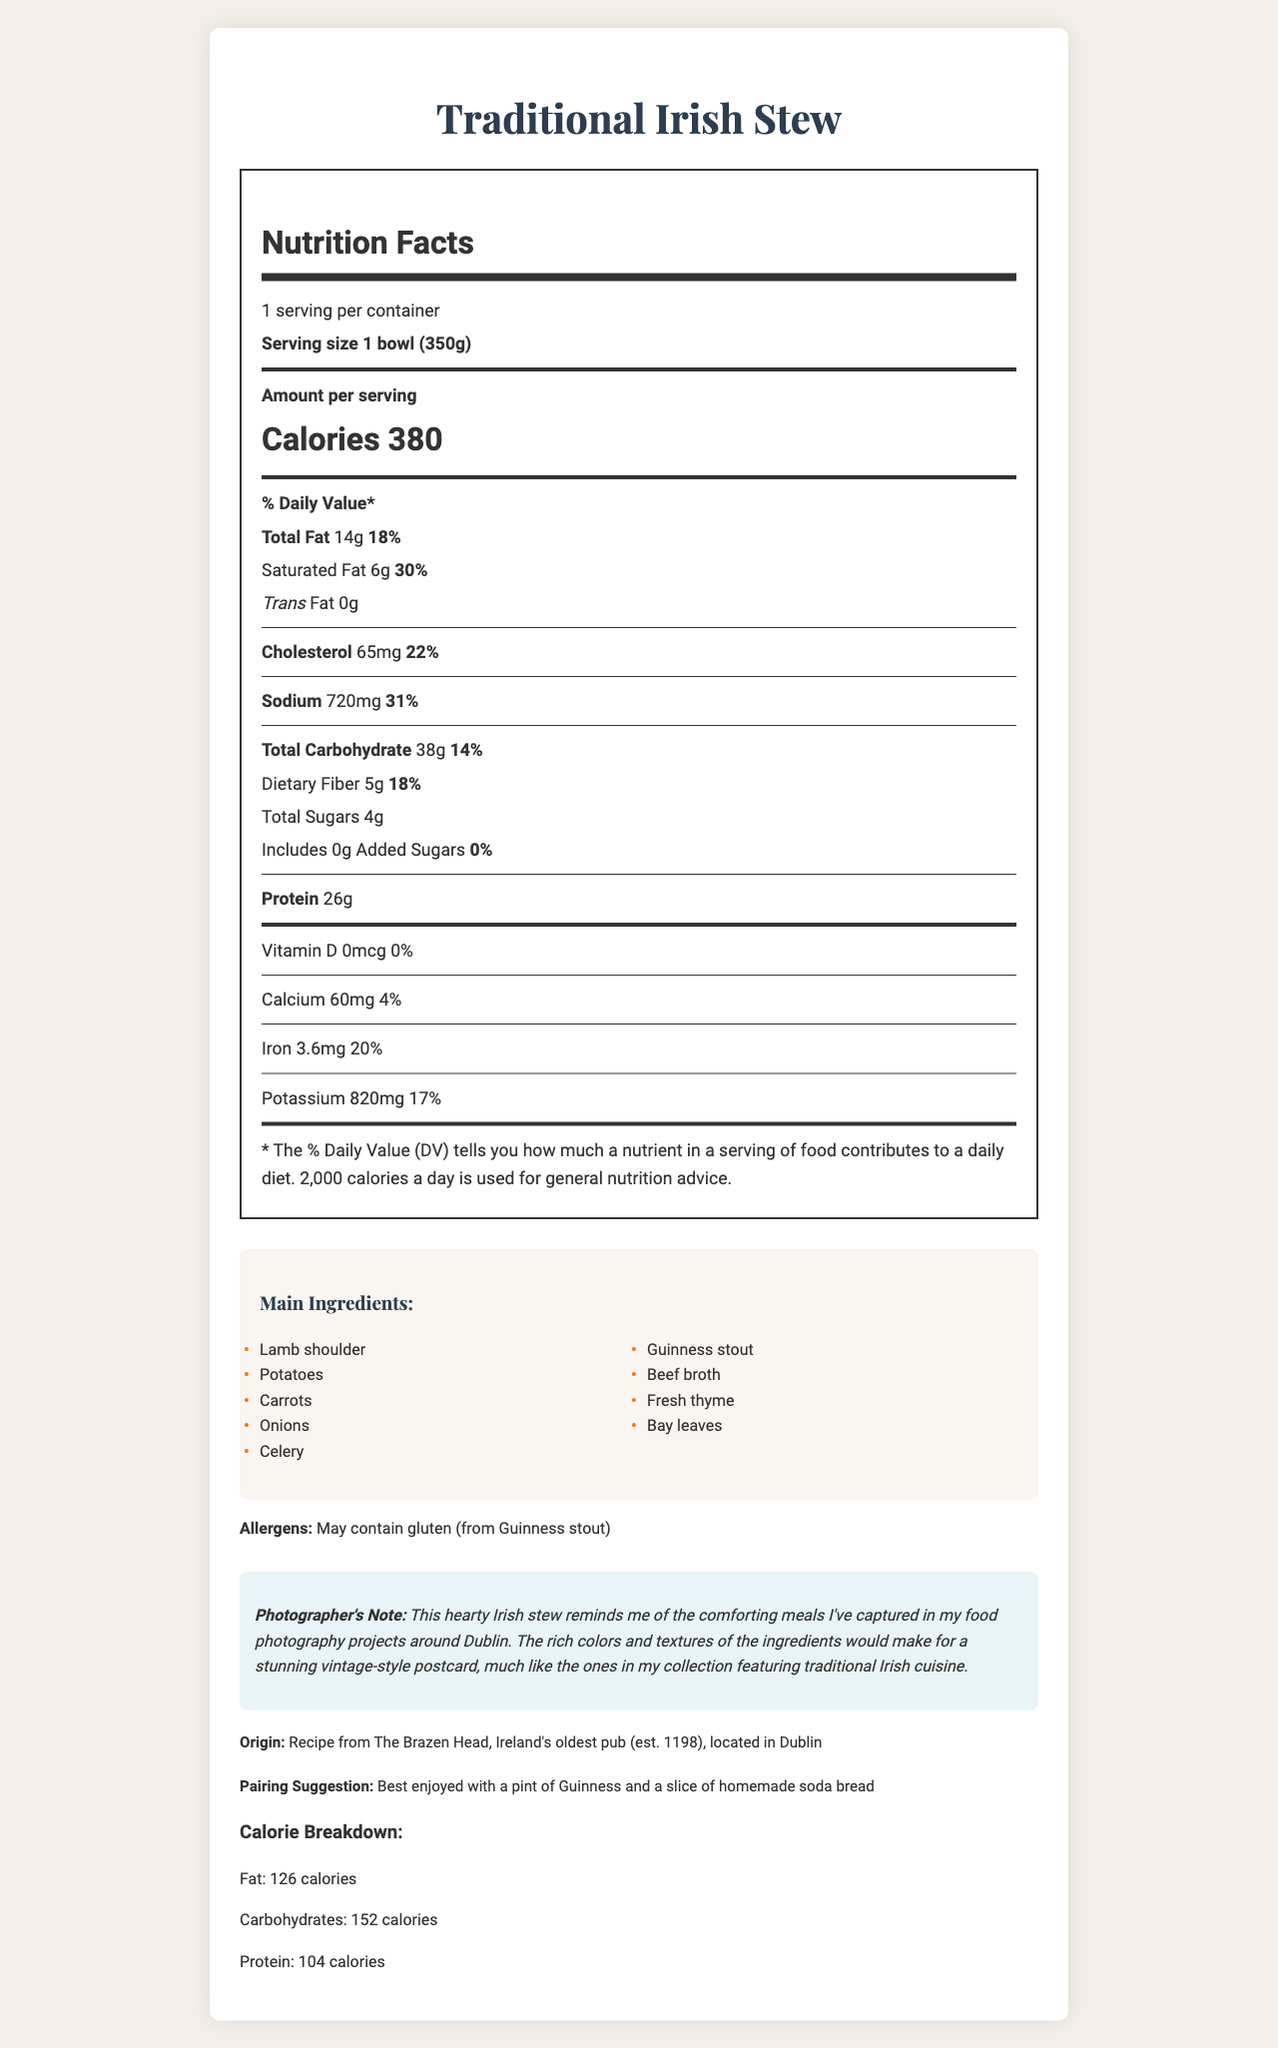what is the serving size? The serving size is specified as "1 bowl (350g)" in the document.
Answer: 1 bowl (350g) how many calories are in one serving? The document states that there are 380 calories in one serving.
Answer: 380 which ingredient in the stew may contain gluten? The allergens section mentions that the stew may contain gluten from Guinness stout.
Answer: Guinness stout what is the total fat content per serving? The document lists the total fat content per serving as 14g.
Answer: 14g how many grams of dietary fiber does the stew contain? The dietary fiber content is listed as 5g per serving.
Answer: 5g how much sodium is in the Irish Stew? A. 500mg B. 650mg C. 720mg D. 820mg The sodium content is 720mg per serving, which matches option C.
Answer: C. 720mg what percentage of daily value of saturated fat does the stew provide? A. 15% B. 30% C. 45% D. 60% The document states that the stew provides 30% of the daily value of saturated fat, corresponding to option B.
Answer: B. 30% is the total carbohydrate content higher or lower than the dietary fiber content? The total carbohydrate content is 38g, which is significantly higher than the dietary fiber content of 5g.
Answer: Higher does the Irish Stew contain any added sugars? (yes/no) The document specifies that the stew includes 0g of added sugars.
Answer: No describe the document summarizing its main points. The summary outlines nutritional facts such as calories, fats, carbohydrates, and proteins, as well as ingredient details, allergens, and suggestions to enhance dining experience. Additionally, it offers historical context and a note from the photographer.
Answer: The document provides detailed nutritional information for a traditional Irish stew, including serving size, calories, and nutrient breakdown. It highlights main ingredients, potential allergens, and suggests a pairing while giving a historical origin and a note from the photographer. what vitamins or minerals are included in the nutritional facts? The document lists Vitamin D, Calcium, Iron, and Potassium in the nutritional facts section.
Answer: Vitamin D, Calcium, Iron, Potassium what type of broth is used in the Irish stew? The main ingredients section includes beef broth.
Answer: Beef broth what is the calorie breakdown of the stew from carbohydrates? A. 104 calories B. 126 calories C. 152 calories D. 380 calories The calorie breakdown section states that carbohydrates contribute 152 calories, matching option C.
Answer: C. 152 calories how many calories come from protein in the traditional Irish stew? The document details that 104 calories come from protein.
Answer: 104 calories what is the total cholesterol per serving? The cholesterol content per serving is listed as 65mg.
Answer: 65mg where is the recipe for the traditional Irish stew from? The origin section states that the recipe is from The Brazen Head, Dublin's oldest pub.
Answer: The Brazen Head, Dublin can the exact number of calories from each main ingredient be determined from this label? The document doesn't provide a detailed calorie breakdown for each individual ingredient.
Answer: Cannot be determined what percentage of daily value for vitamin D does the Irish stew provide? The document indicates that the stew provides 0% of the daily value for Vitamin D.
Answer: 0% 